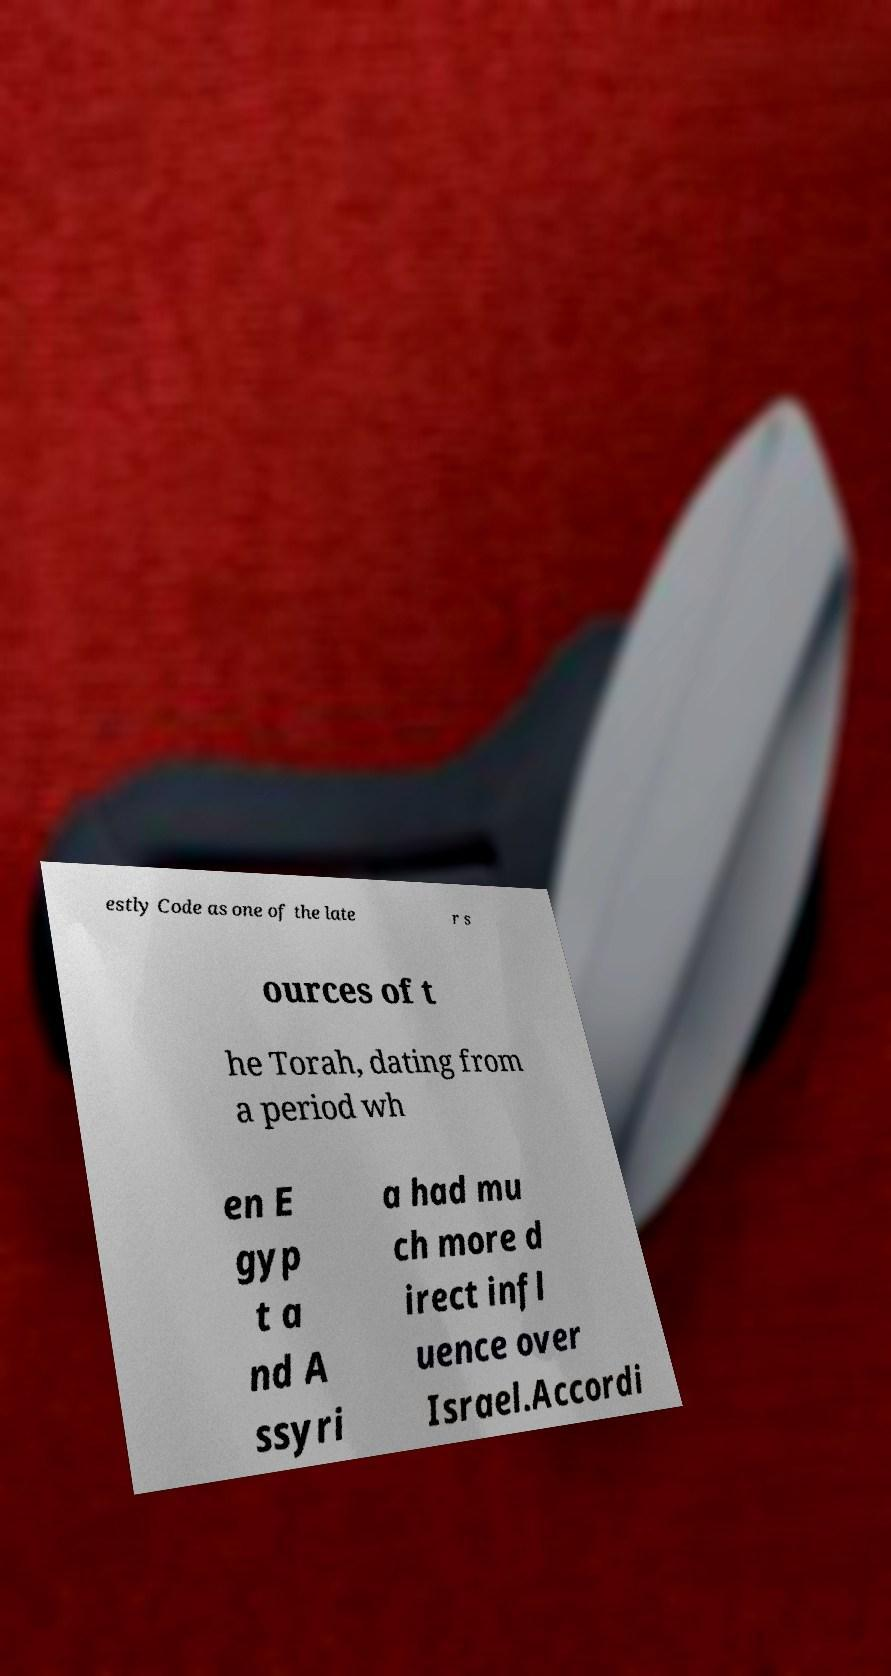Can you read and provide the text displayed in the image?This photo seems to have some interesting text. Can you extract and type it out for me? estly Code as one of the late r s ources of t he Torah, dating from a period wh en E gyp t a nd A ssyri a had mu ch more d irect infl uence over Israel.Accordi 